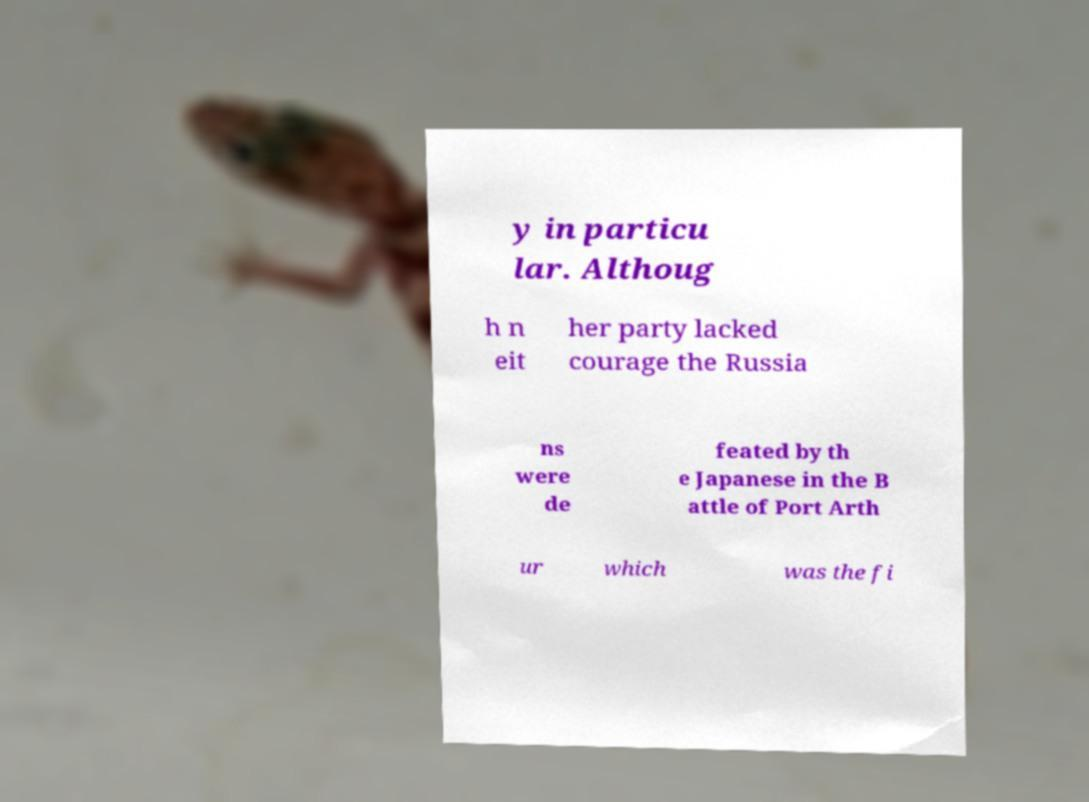What messages or text are displayed in this image? I need them in a readable, typed format. y in particu lar. Althoug h n eit her party lacked courage the Russia ns were de feated by th e Japanese in the B attle of Port Arth ur which was the fi 